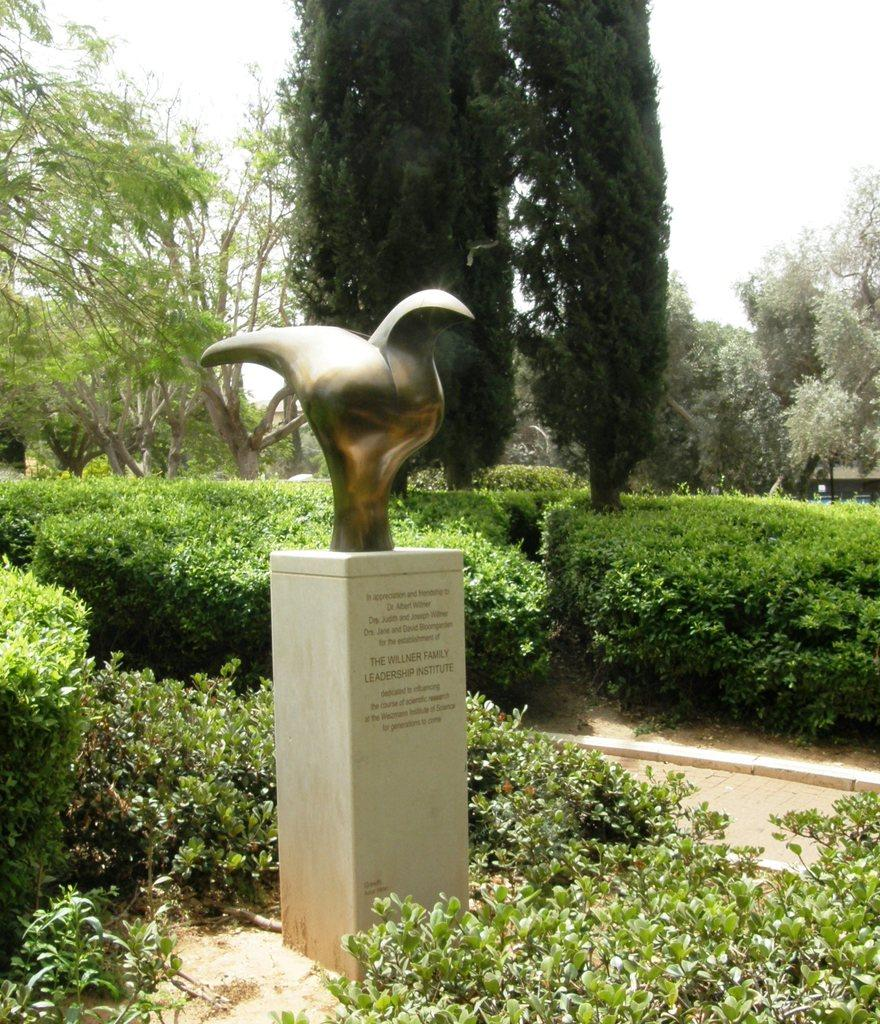What type of plants can be seen in the image? There are green color plants in the image. Can you describe any specific plant in the image? There is a tree in the image. What is visible at the top of the image? The sky is visible at the top of the image. What type of brick is used to build the tree in the image? There is no brick used to build the tree in the image; it is a natural plant. What emotion is being expressed by the plants in the image? The plants in the image do not express emotions, as they are inanimate objects. 